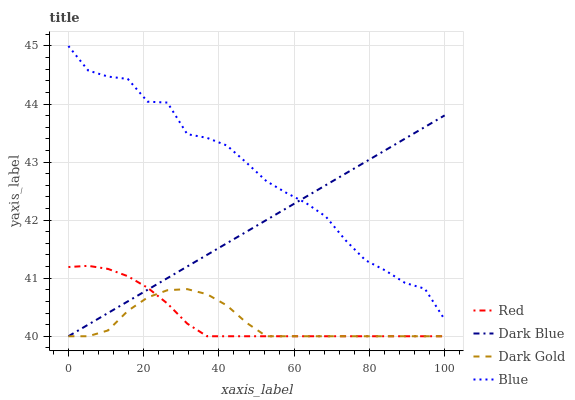Does Dark Gold have the minimum area under the curve?
Answer yes or no. Yes. Does Blue have the maximum area under the curve?
Answer yes or no. Yes. Does Dark Blue have the minimum area under the curve?
Answer yes or no. No. Does Dark Blue have the maximum area under the curve?
Answer yes or no. No. Is Dark Blue the smoothest?
Answer yes or no. Yes. Is Blue the roughest?
Answer yes or no. Yes. Is Red the smoothest?
Answer yes or no. No. Is Red the roughest?
Answer yes or no. No. Does Dark Blue have the lowest value?
Answer yes or no. Yes. Does Blue have the highest value?
Answer yes or no. Yes. Does Dark Blue have the highest value?
Answer yes or no. No. Is Red less than Blue?
Answer yes or no. Yes. Is Blue greater than Red?
Answer yes or no. Yes. Does Dark Blue intersect Red?
Answer yes or no. Yes. Is Dark Blue less than Red?
Answer yes or no. No. Is Dark Blue greater than Red?
Answer yes or no. No. Does Red intersect Blue?
Answer yes or no. No. 